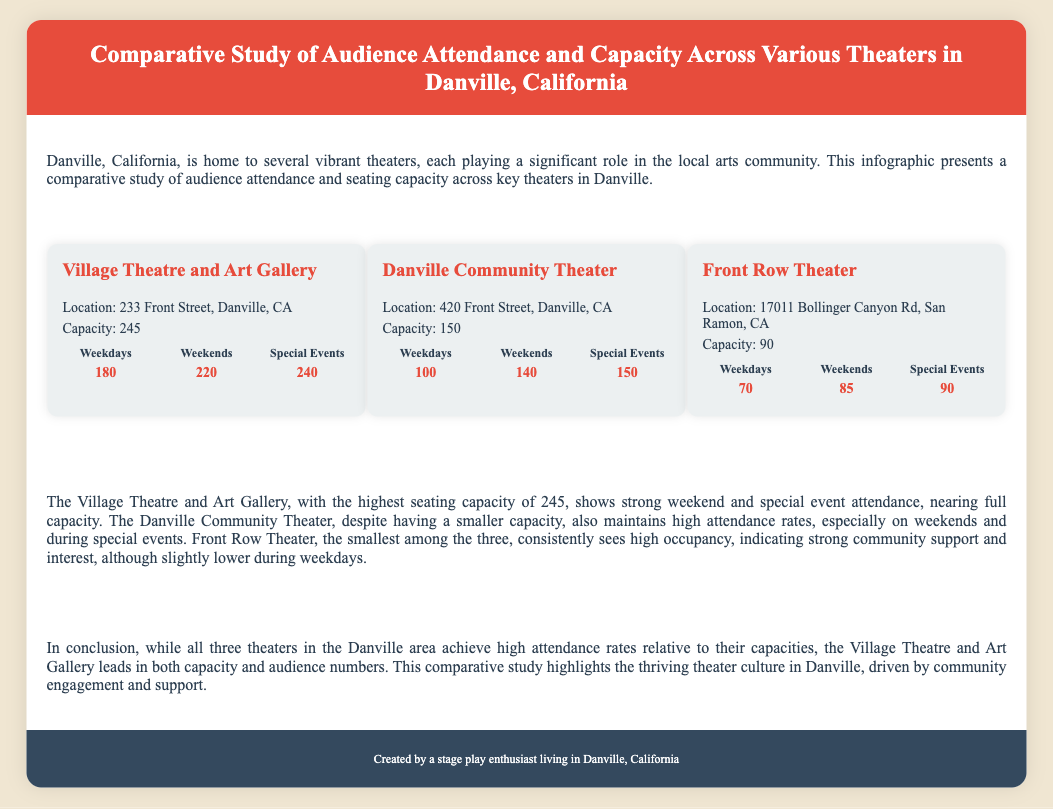What is the location of the Village Theatre and Art Gallery? The location is mentioned in the section for the Village Theatre and Art Gallery.
Answer: 233 Front Street, Danville, CA What is the seating capacity of the Danville Community Theater? The capacity is stated under the Danville Community Theater information section.
Answer: 150 How many attendees were there during weekends at Front Row Theater? The number of attendees during weekends is indicated in the attendance section for Front Row Theater.
Answer: 85 Which theater has the highest special event attendance? This information can be inferred by comparing the special event attendance figures for each theater.
Answer: Village Theatre and Art Gallery What is the total capacity of all three theaters combined? The total capacity is the sum of the individual capacities listed. 245 + 150 + 90 = 485.
Answer: 485 What does the analysis section emphasize regarding the Village Theatre and Art Gallery? The analysis highlights the strong attendance of the Village Theatre and Art Gallery during weekends and special events.
Answer: Strong weekend and special event attendance Which theater is the smallest in seating capacity? This is indicated in the seating capacity information provided for each theater.
Answer: Front Row Theater What color is used for the header background? The document mentions specific colors used for different sections, including the header.
Answer: Red 